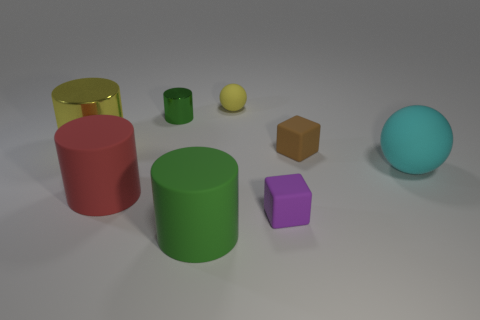Subtract all big cylinders. How many cylinders are left? 1 Subtract all cyan spheres. How many spheres are left? 1 Subtract 2 balls. How many balls are left? 0 Subtract all cubes. How many objects are left? 6 Add 2 cyan cylinders. How many objects exist? 10 Subtract all small red matte cylinders. Subtract all spheres. How many objects are left? 6 Add 1 big green matte things. How many big green matte things are left? 2 Add 6 tiny metal cylinders. How many tiny metal cylinders exist? 7 Subtract 0 purple cylinders. How many objects are left? 8 Subtract all cyan blocks. Subtract all green spheres. How many blocks are left? 2 